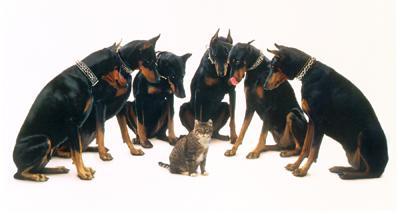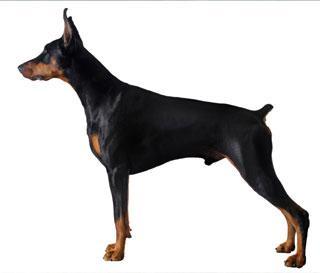The first image is the image on the left, the second image is the image on the right. Considering the images on both sides, is "The left image shows a doberman wearing a collar, and the right image shows a doberman sitting upright without a collar on." valid? Answer yes or no. No. The first image is the image on the left, the second image is the image on the right. Evaluate the accuracy of this statement regarding the images: "More than one doberman is sitting.". Is it true? Answer yes or no. Yes. 